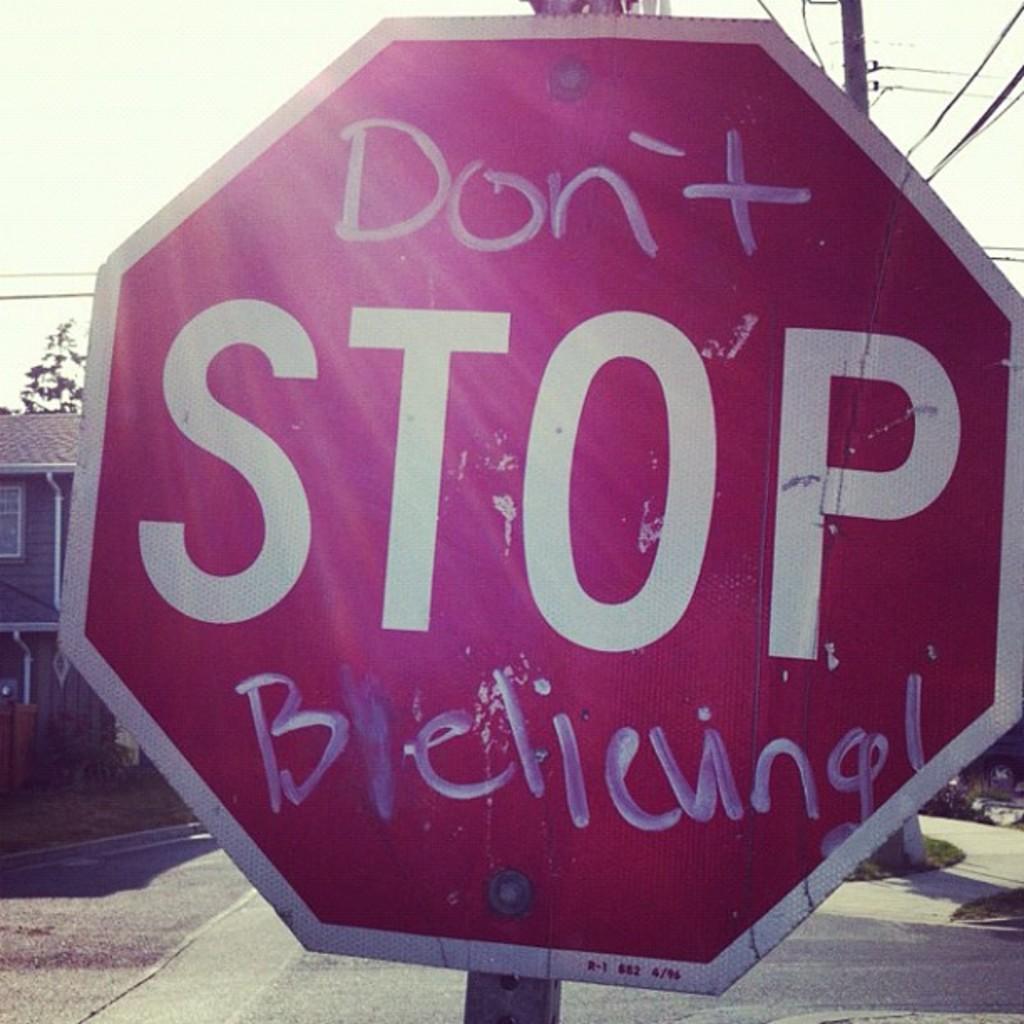What kind of sign is this?
Provide a succinct answer. Stop. What does it say above stop?
Give a very brief answer. Don't. 